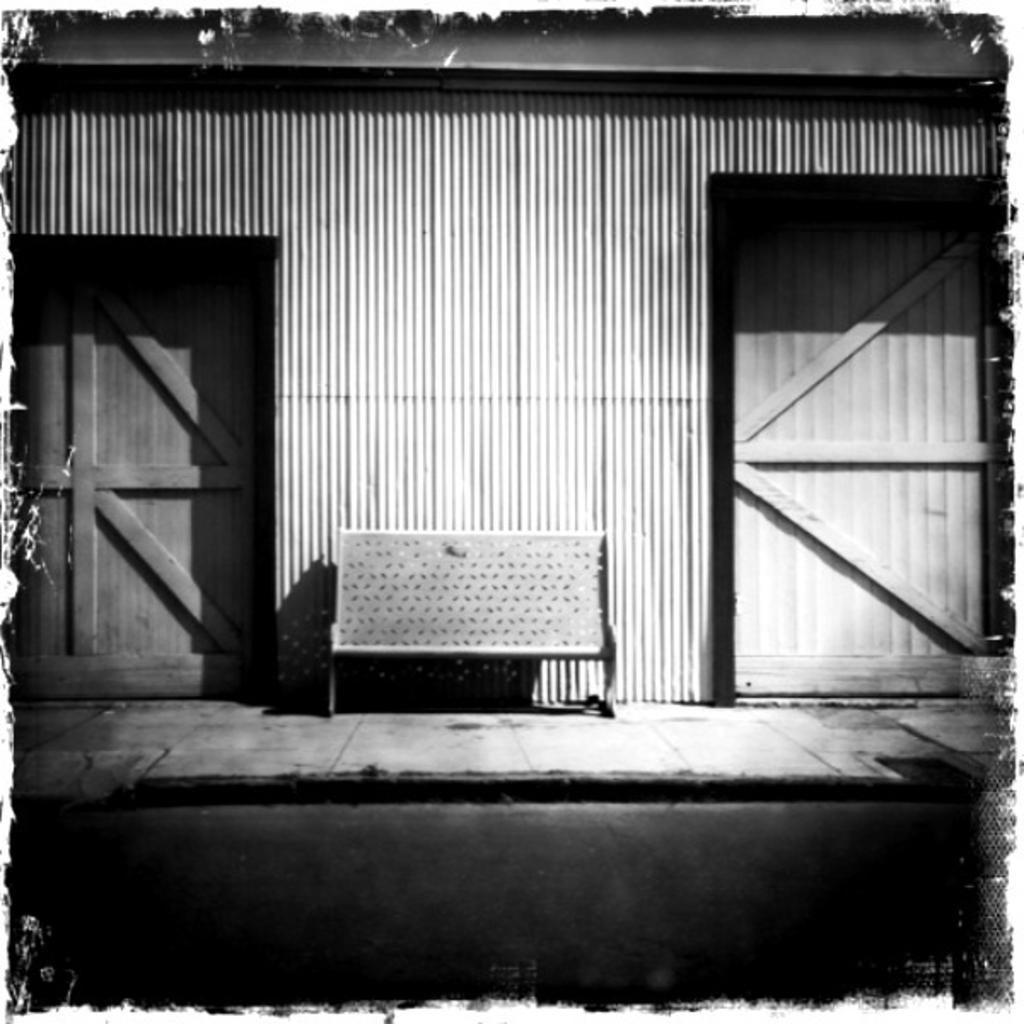What type of furniture is in the image? There is a wooden bench in the image. What other wooden objects can be seen in the image? There are wooden doors in the image. What do the wooden doors lead to? The wooden doors lead to a house. What degree of difficulty is required to grip the wooden bench in the image? There is no need to grip the wooden bench in the image, as it is a stationary object. 